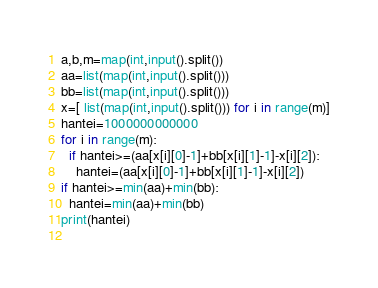Convert code to text. <code><loc_0><loc_0><loc_500><loc_500><_Python_>a,b,m=map(int,input().split())
aa=list(map(int,input().split()))
bb=list(map(int,input().split()))
x=[ list(map(int,input().split())) for i in range(m)]
hantei=1000000000000
for i in range(m):
  if hantei>=(aa[x[i][0]-1]+bb[x[i][1]-1]-x[i][2]):
    hantei=(aa[x[i][0]-1]+bb[x[i][1]-1]-x[i][2])
if hantei>=min(aa)+min(bb):
  hantei=min(aa)+min(bb)
print(hantei)
    </code> 